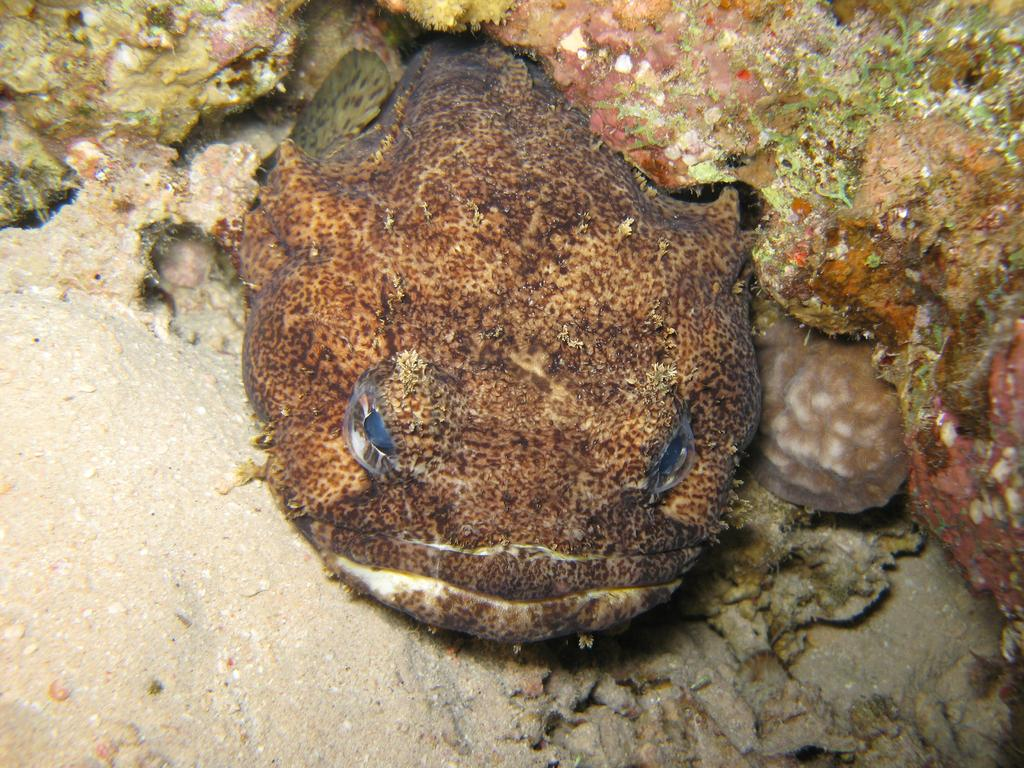What type of fish is in the image? There is a toad fish in the image. What is the toad fish positioned in front of? The toad fish is in front of a rock. How many visitors can be seen in the image? There are no visitors present in the image; it only features a toad fish in front of a rock. 